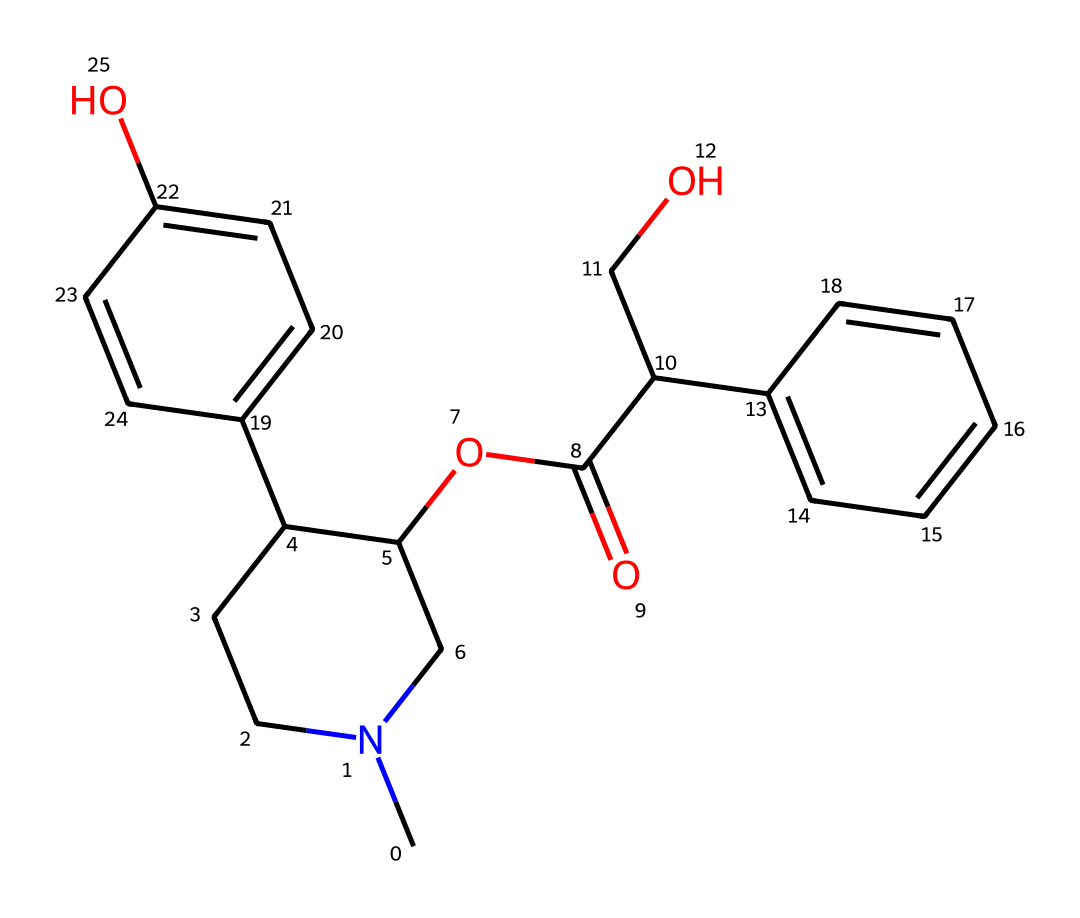What is the molecular formula of atropine? To determine the molecular formula, count the number of each type of atom present in the SMILES representation. The formula consists of 18 carbon (C), 23 hydrogen (H), 1 nitrogen (N), and 3 oxygen (O) atoms. Therefore, the molecular formula will include all these elements.
Answer: C18H23N1O3 How many rings are present in the structure of atropine? Analyzing the chemical structure indicates the presence of multiple cycles. Count the distinct closed loops formed by the carbon atoms. In this case, there are two rings in the molecular structure of atropine.
Answer: 2 What is the functional group present in atropine? By examining the structure represented in the SMILES, we can identify the functional groups. The presence of a hydroxyl group (-OH) and an ester group (-COO) is evident. Therefore, the hydroxyl and ester are the primary functional groups.
Answer: hydroxyl and ester What type of alkaloid is atropine classified as? Examining the structure reveals that atropine is derived from tropane, a bicyclic structure common in various alkaloids. Atropine is specifically classified as a tertiary alkaloid since it contains a nitrogen atom that is attached to three substituents.
Answer: tertiary alkaloid How many oxygen atoms are in the atropine structure? Look closely at the chemical structure to count the number of oxygen atoms present. The SMILES indicates three oxygen atoms in total. Therefore, the answer will reflect that count.
Answer: 3 Which part of the molecule gives atropine its pharmacological activity? To determine this, we need to identify the region of the molecule that interacts with biological receptors. The nitrogen atom, part of the tropane ring structure, is crucial for binding to muscarinic acetylcholine receptors, thus providing the pharmacological activity.
Answer: nitrogen atom 